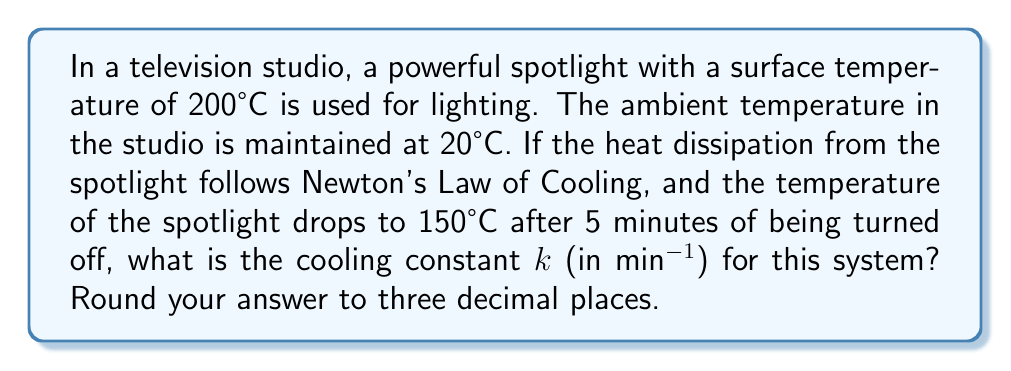What is the answer to this math problem? To solve this problem, we'll use Newton's Law of Cooling and follow these steps:

1) Newton's Law of Cooling is given by the equation:
   $$\frac{dT}{dt} = -k(T - T_a)$$
   where T is the temperature of the object, T_a is the ambient temperature, t is time, and k is the cooling constant.

2) The solution to this differential equation is:
   $$T(t) = T_a + (T_0 - T_a)e^{-kt}$$
   where T_0 is the initial temperature of the object.

3) Let's plug in our known values:
   T_a = 20°C (ambient temperature)
   T_0 = 200°C (initial spotlight temperature)
   T(5) = 150°C (temperature after 5 minutes)
   t = 5 minutes

4) Substituting these into our equation:
   $$150 = 20 + (200 - 20)e^{-5k}$$

5) Simplify:
   $$130 = 180e^{-5k}$$

6) Divide both sides by 180:
   $$\frac{13}{18} = e^{-5k}$$

7) Take the natural log of both sides:
   $$\ln(\frac{13}{18}) = -5k$$

8) Solve for k:
   $$k = -\frac{1}{5}\ln(\frac{13}{18}) \approx 0.0662$$

9) Rounding to three decimal places:
   k ≈ 0.066 min⁻¹
Answer: 0.066 min⁻¹ 